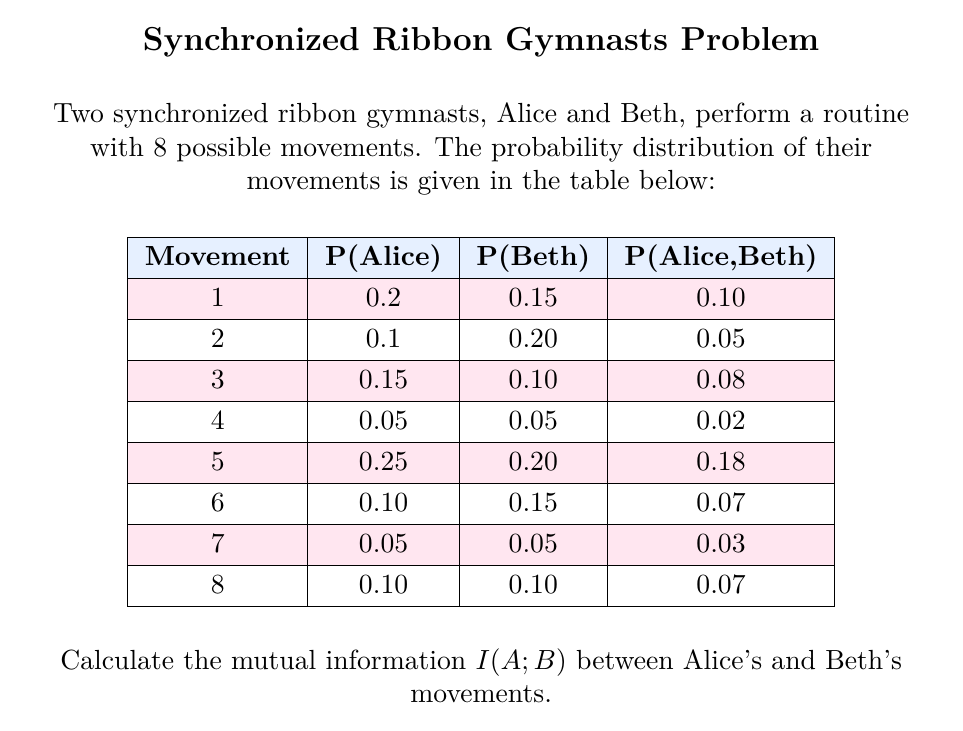Can you solve this math problem? To calculate the mutual information $I(A;B)$, we'll follow these steps:

1) The mutual information formula is:
   $$I(A;B) = \sum_{a,b} P(a,b) \log_2 \frac{P(a,b)}{P(a)P(b)}$$

2) We need to calculate this for each movement:

   For movement 1:
   $P(A=1,B=1) = 0.10$
   $P(A=1) = 0.20$
   $P(B=1) = 0.15$
   $\frac{P(A=1,B=1)}{P(A=1)P(B=1)} = \frac{0.10}{0.20 \times 0.15} = 3.33$
   $0.10 \log_2(3.33) = 0.1737$

3) Repeating this for all movements:

   Movement 2: $0.05 \log_2(\frac{0.05}{0.1 \times 0.20}) = 0.0321$
   Movement 3: $0.08 \log_2(\frac{0.08}{0.15 \times 0.10}) = 0.1699$
   Movement 4: $0.02 \log_2(\frac{0.02}{0.05 \times 0.05}) = 0.0722$
   Movement 5: $0.18 \log_2(\frac{0.18}{0.25 \times 0.20}) = 0.0623$
   Movement 6: $0.07 \log_2(\frac{0.07}{0.10 \times 0.15}) = 0.0612$
   Movement 7: $0.03 \log_2(\frac{0.03}{0.05 \times 0.05}) = 0.1083$
   Movement 8: $0.07 \log_2(\frac{0.07}{0.10 \times 0.10}) = 0.0807$

4) Sum all these values:

   $I(A;B) = 0.1737 + 0.0321 + 0.1699 + 0.0722 + 0.0623 + 0.0612 + 0.1083 + 0.0807 = 0.7604$

Therefore, the mutual information $I(A;B)$ is approximately 0.7604 bits.
Answer: $0.7604$ bits 